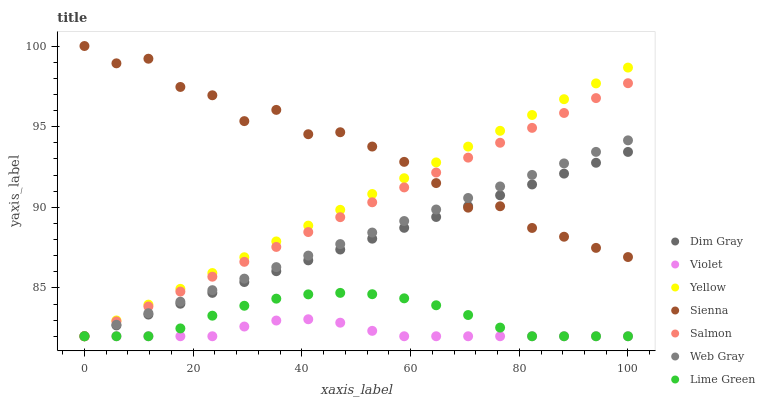Does Violet have the minimum area under the curve?
Answer yes or no. Yes. Does Sienna have the maximum area under the curve?
Answer yes or no. Yes. Does Salmon have the minimum area under the curve?
Answer yes or no. No. Does Salmon have the maximum area under the curve?
Answer yes or no. No. Is Dim Gray the smoothest?
Answer yes or no. Yes. Is Sienna the roughest?
Answer yes or no. Yes. Is Salmon the smoothest?
Answer yes or no. No. Is Salmon the roughest?
Answer yes or no. No. Does Web Gray have the lowest value?
Answer yes or no. Yes. Does Sienna have the lowest value?
Answer yes or no. No. Does Sienna have the highest value?
Answer yes or no. Yes. Does Salmon have the highest value?
Answer yes or no. No. Is Violet less than Sienna?
Answer yes or no. Yes. Is Sienna greater than Violet?
Answer yes or no. Yes. Does Web Gray intersect Lime Green?
Answer yes or no. Yes. Is Web Gray less than Lime Green?
Answer yes or no. No. Is Web Gray greater than Lime Green?
Answer yes or no. No. Does Violet intersect Sienna?
Answer yes or no. No. 